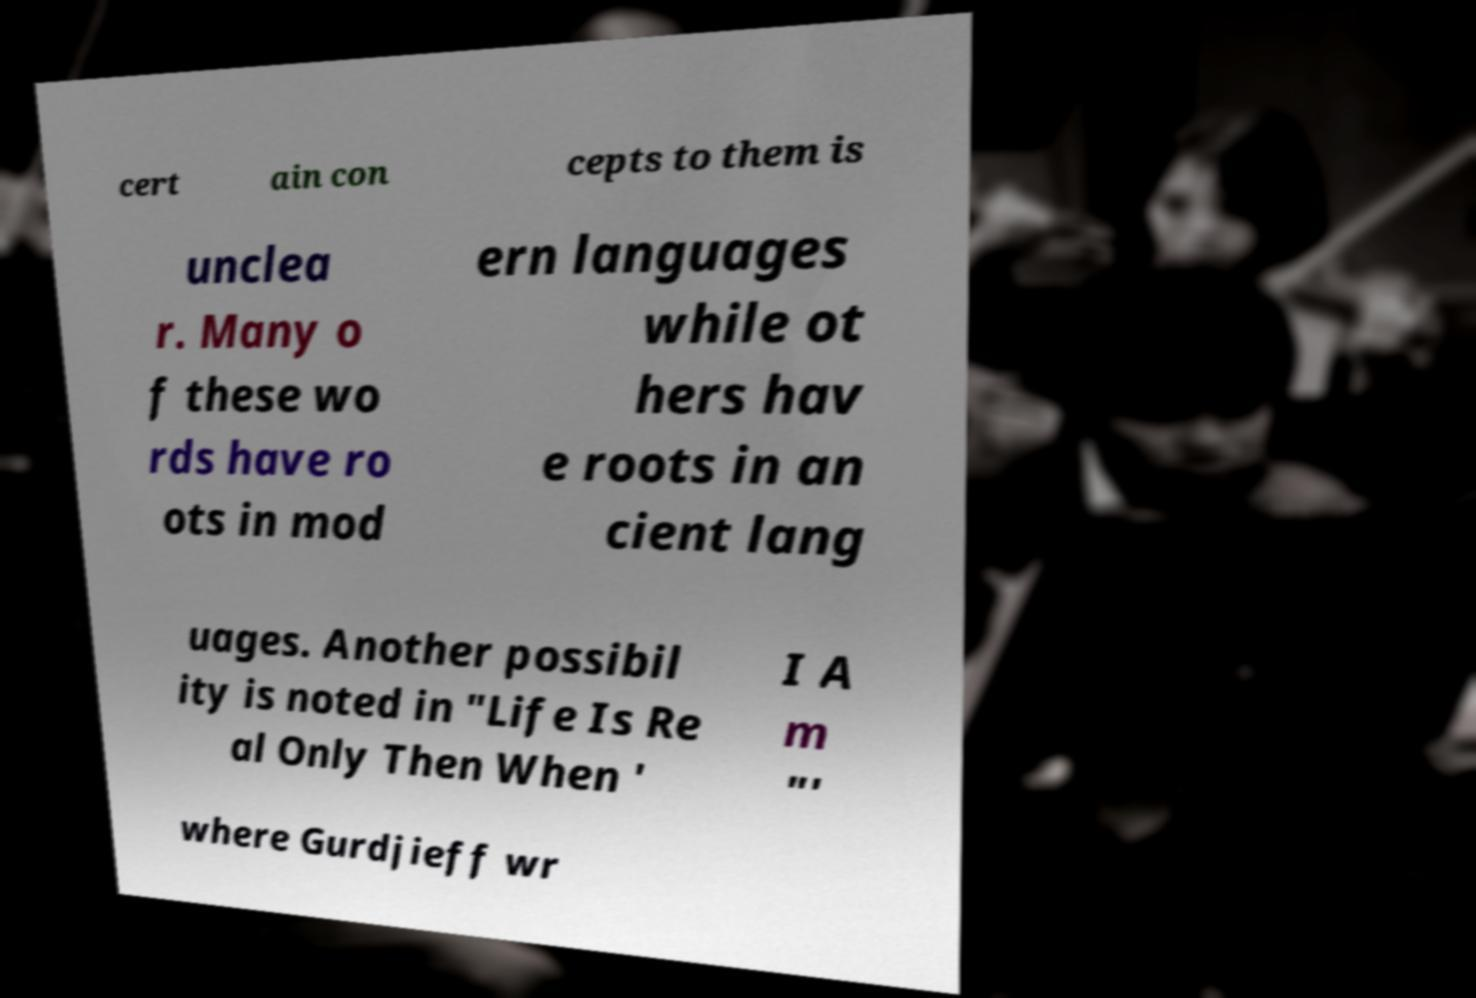What messages or text are displayed in this image? I need them in a readable, typed format. cert ain con cepts to them is unclea r. Many o f these wo rds have ro ots in mod ern languages while ot hers hav e roots in an cient lang uages. Another possibil ity is noted in "Life Is Re al Only Then When ' I A m "' where Gurdjieff wr 